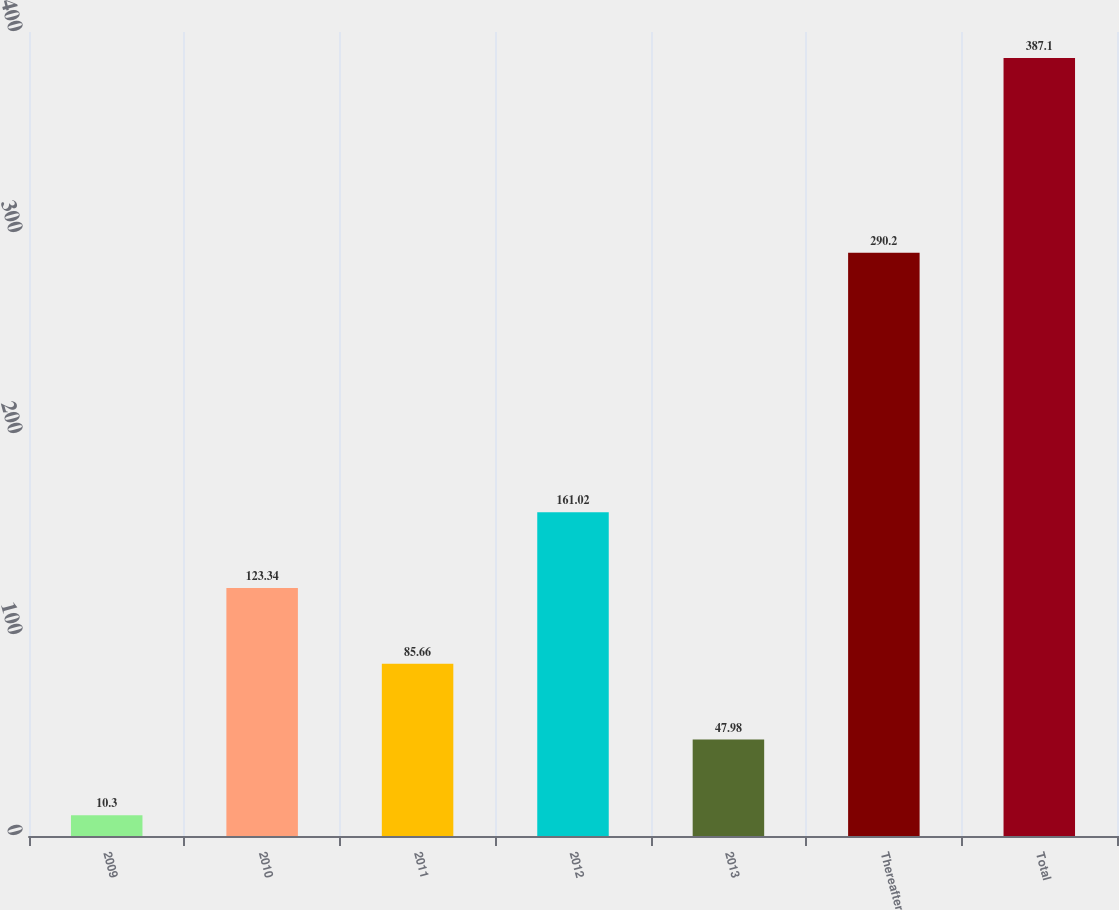Convert chart. <chart><loc_0><loc_0><loc_500><loc_500><bar_chart><fcel>2009<fcel>2010<fcel>2011<fcel>2012<fcel>2013<fcel>Thereafter<fcel>Total<nl><fcel>10.3<fcel>123.34<fcel>85.66<fcel>161.02<fcel>47.98<fcel>290.2<fcel>387.1<nl></chart> 